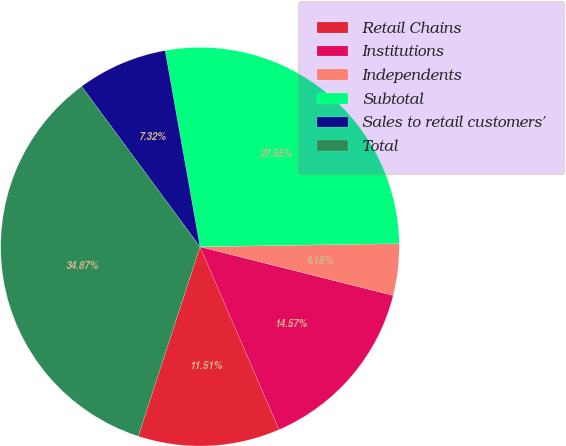<chart> <loc_0><loc_0><loc_500><loc_500><pie_chart><fcel>Retail Chains<fcel>Institutions<fcel>Independents<fcel>Subtotal<fcel>Sales to retail customers'<fcel>Total<nl><fcel>11.51%<fcel>14.57%<fcel>4.18%<fcel>27.55%<fcel>7.32%<fcel>34.87%<nl></chart> 